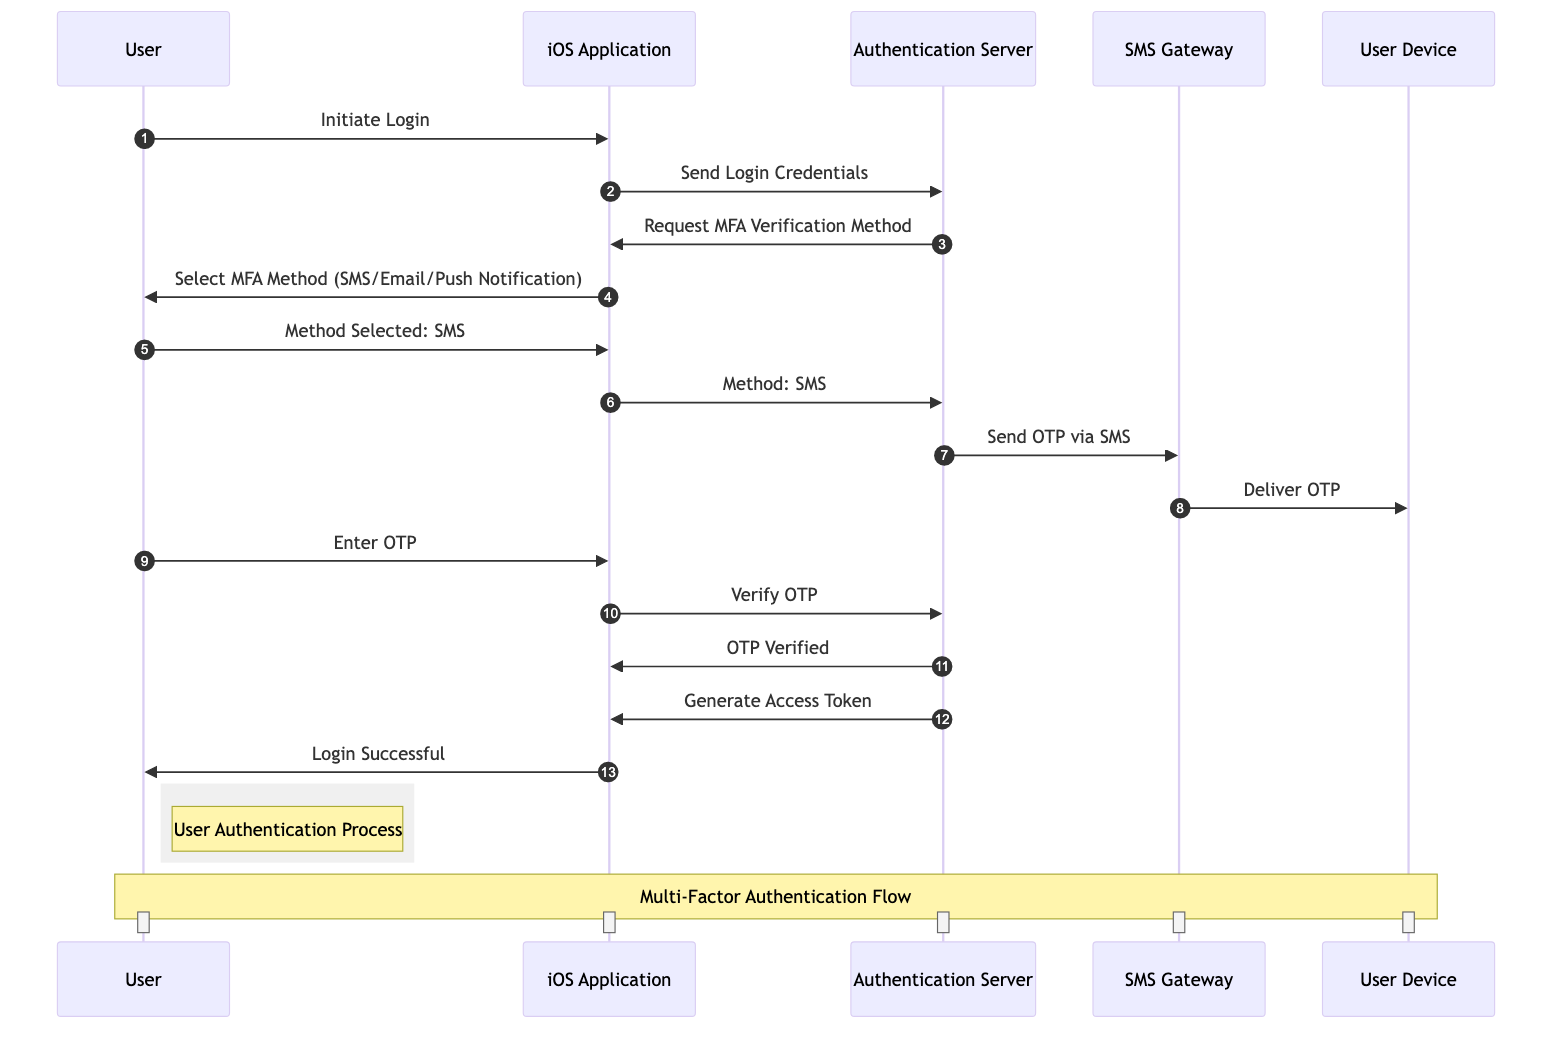What is the first action the User takes? The User initiates the process by sending a message to the iOS Application which is labeled as "Initiate Login".
Answer: Initiate Login How many actors are involved in the sequence diagram? By counting the listed actors in the diagram, we identify five distinct entities: User, iOS Application, Authentication Server, SMS Gateway, and Email Server.
Answer: 5 Who requests the Multi-Factor Authentication verification method? The Authentication Server sends a request to the iOS Application for the Multi-Factor Authentication verification method, as indicated in the message labeled "Request MFA Verification Method".
Answer: Authentication Server Which method does the User select for Multi-Factor Authentication? The User selects SMS as indicated by their message "Method Selected: SMS" in response to the iOS Application's prompt.
Answer: SMS What is delivered to the User Device after sending the OTP via SMS? The SMS Gateway delivers the One-Time Password to the User Device, which is referred to as "Deliver OTP" in the diagram.
Answer: OTP What is the final outcome of the authentication process? After verifying the OTP and generating the Access Token, the final message sent from the iOS Application to the User is "Login Successful".
Answer: Login Successful Which component generates the Access Token? The Access Token is generated by the Authentication Server, as shown in the sequence with the message "Generate Access Token".
Answer: Authentication Server What does the User do after receiving the OTP? The User enters the One-Time Password into the iOS Application, as shown by the message "Enter OTP".
Answer: Enter OTP What is the sequence of sending the OTP via SMS? The sequence includes three key messages: the Authentication Server sends an OTP request to the SMS Gateway, which then delivers the OTP to the User Device.
Answer: SMS Gateway to User Device 